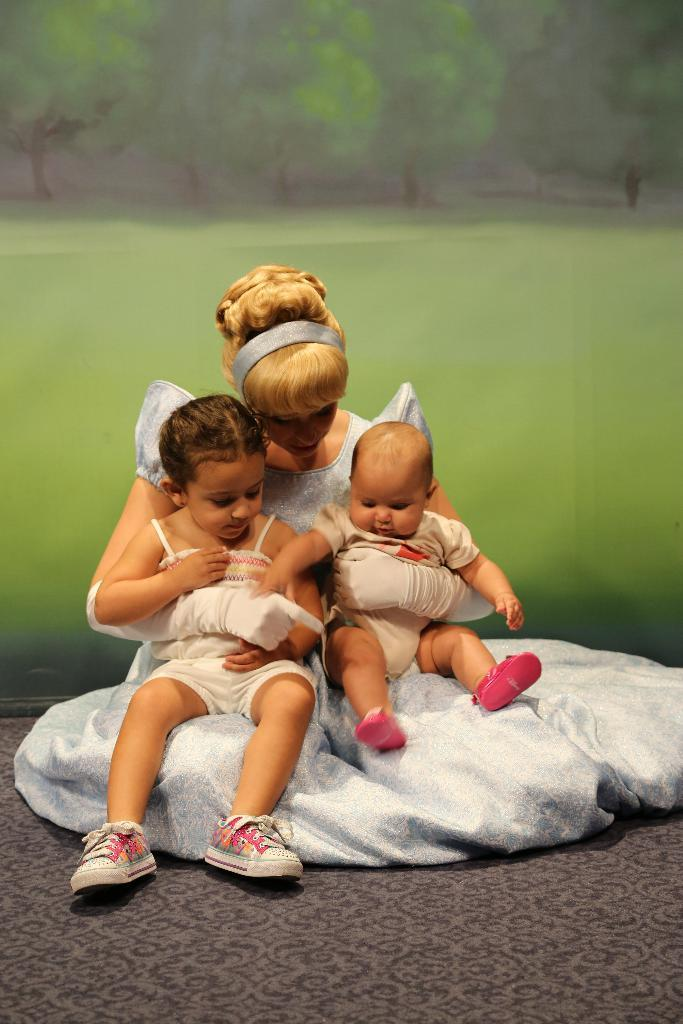Who is the main subject in the image? There is a woman in the image. What is the woman doing in the image? The woman is sitting on the floor and holding two babies. What is the woman wearing in the image? The woman is wearing a white gown. What can be seen in the background of the image? There is wallpaper with greenery in the background of the image. What type of store can be seen in the background of the image? There is no store present in the image; the background features wallpaper with greenery. What idea does the woman have for the babies in the image? The image does not provide any information about the woman's ideas or intentions for the babies. 